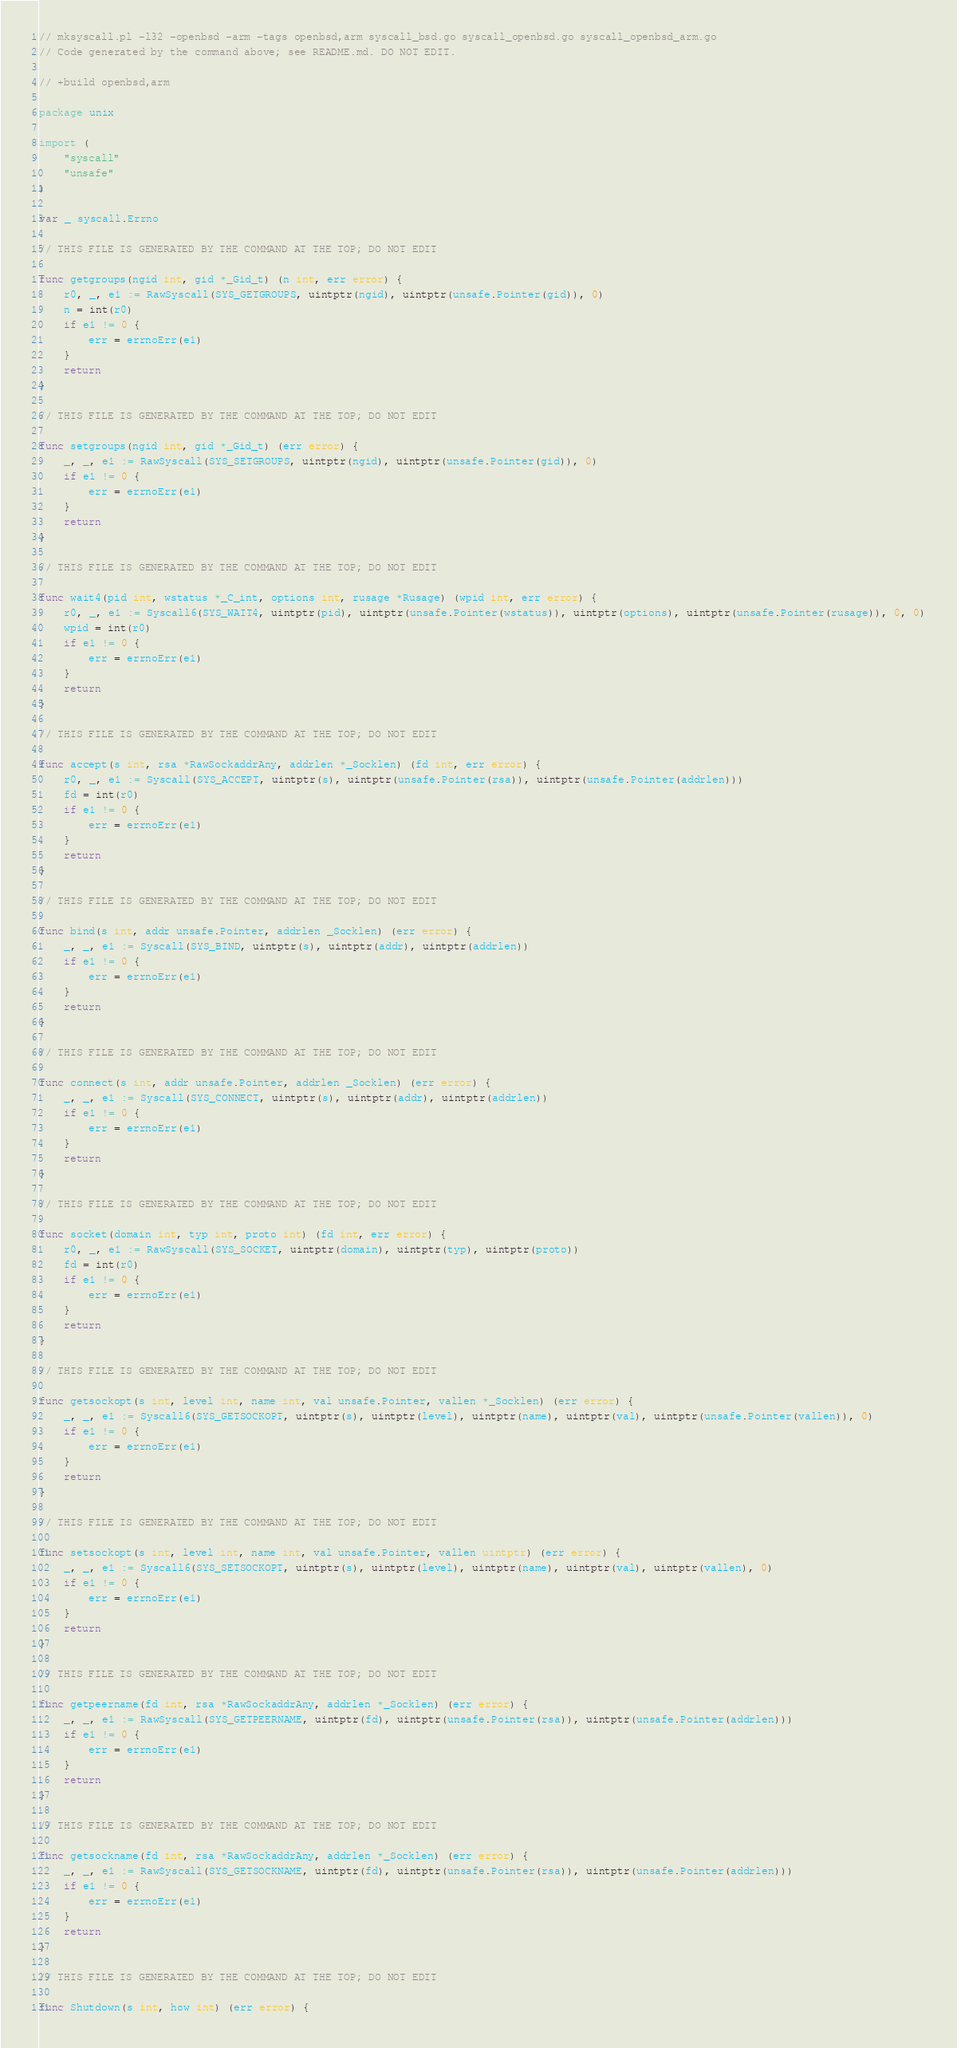Convert code to text. <code><loc_0><loc_0><loc_500><loc_500><_Go_>// mksyscall.pl -l32 -openbsd -arm -tags openbsd,arm syscall_bsd.go syscall_openbsd.go syscall_openbsd_arm.go
// Code generated by the command above; see README.md. DO NOT EDIT.

// +build openbsd,arm

package unix

import (
	"syscall"
	"unsafe"
)

var _ syscall.Errno

// THIS FILE IS GENERATED BY THE COMMAND AT THE TOP; DO NOT EDIT

func getgroups(ngid int, gid *_Gid_t) (n int, err error) {
	r0, _, e1 := RawSyscall(SYS_GETGROUPS, uintptr(ngid), uintptr(unsafe.Pointer(gid)), 0)
	n = int(r0)
	if e1 != 0 {
		err = errnoErr(e1)
	}
	return
}

// THIS FILE IS GENERATED BY THE COMMAND AT THE TOP; DO NOT EDIT

func setgroups(ngid int, gid *_Gid_t) (err error) {
	_, _, e1 := RawSyscall(SYS_SETGROUPS, uintptr(ngid), uintptr(unsafe.Pointer(gid)), 0)
	if e1 != 0 {
		err = errnoErr(e1)
	}
	return
}

// THIS FILE IS GENERATED BY THE COMMAND AT THE TOP; DO NOT EDIT

func wait4(pid int, wstatus *_C_int, options int, rusage *Rusage) (wpid int, err error) {
	r0, _, e1 := Syscall6(SYS_WAIT4, uintptr(pid), uintptr(unsafe.Pointer(wstatus)), uintptr(options), uintptr(unsafe.Pointer(rusage)), 0, 0)
	wpid = int(r0)
	if e1 != 0 {
		err = errnoErr(e1)
	}
	return
}

// THIS FILE IS GENERATED BY THE COMMAND AT THE TOP; DO NOT EDIT

func accept(s int, rsa *RawSockaddrAny, addrlen *_Socklen) (fd int, err error) {
	r0, _, e1 := Syscall(SYS_ACCEPT, uintptr(s), uintptr(unsafe.Pointer(rsa)), uintptr(unsafe.Pointer(addrlen)))
	fd = int(r0)
	if e1 != 0 {
		err = errnoErr(e1)
	}
	return
}

// THIS FILE IS GENERATED BY THE COMMAND AT THE TOP; DO NOT EDIT

func bind(s int, addr unsafe.Pointer, addrlen _Socklen) (err error) {
	_, _, e1 := Syscall(SYS_BIND, uintptr(s), uintptr(addr), uintptr(addrlen))
	if e1 != 0 {
		err = errnoErr(e1)
	}
	return
}

// THIS FILE IS GENERATED BY THE COMMAND AT THE TOP; DO NOT EDIT

func connect(s int, addr unsafe.Pointer, addrlen _Socklen) (err error) {
	_, _, e1 := Syscall(SYS_CONNECT, uintptr(s), uintptr(addr), uintptr(addrlen))
	if e1 != 0 {
		err = errnoErr(e1)
	}
	return
}

// THIS FILE IS GENERATED BY THE COMMAND AT THE TOP; DO NOT EDIT

func socket(domain int, typ int, proto int) (fd int, err error) {
	r0, _, e1 := RawSyscall(SYS_SOCKET, uintptr(domain), uintptr(typ), uintptr(proto))
	fd = int(r0)
	if e1 != 0 {
		err = errnoErr(e1)
	}
	return
}

// THIS FILE IS GENERATED BY THE COMMAND AT THE TOP; DO NOT EDIT

func getsockopt(s int, level int, name int, val unsafe.Pointer, vallen *_Socklen) (err error) {
	_, _, e1 := Syscall6(SYS_GETSOCKOPT, uintptr(s), uintptr(level), uintptr(name), uintptr(val), uintptr(unsafe.Pointer(vallen)), 0)
	if e1 != 0 {
		err = errnoErr(e1)
	}
	return
}

// THIS FILE IS GENERATED BY THE COMMAND AT THE TOP; DO NOT EDIT

func setsockopt(s int, level int, name int, val unsafe.Pointer, vallen uintptr) (err error) {
	_, _, e1 := Syscall6(SYS_SETSOCKOPT, uintptr(s), uintptr(level), uintptr(name), uintptr(val), uintptr(vallen), 0)
	if e1 != 0 {
		err = errnoErr(e1)
	}
	return
}

// THIS FILE IS GENERATED BY THE COMMAND AT THE TOP; DO NOT EDIT

func getpeername(fd int, rsa *RawSockaddrAny, addrlen *_Socklen) (err error) {
	_, _, e1 := RawSyscall(SYS_GETPEERNAME, uintptr(fd), uintptr(unsafe.Pointer(rsa)), uintptr(unsafe.Pointer(addrlen)))
	if e1 != 0 {
		err = errnoErr(e1)
	}
	return
}

// THIS FILE IS GENERATED BY THE COMMAND AT THE TOP; DO NOT EDIT

func getsockname(fd int, rsa *RawSockaddrAny, addrlen *_Socklen) (err error) {
	_, _, e1 := RawSyscall(SYS_GETSOCKNAME, uintptr(fd), uintptr(unsafe.Pointer(rsa)), uintptr(unsafe.Pointer(addrlen)))
	if e1 != 0 {
		err = errnoErr(e1)
	}
	return
}

// THIS FILE IS GENERATED BY THE COMMAND AT THE TOP; DO NOT EDIT

func Shutdown(s int, how int) (err error) {</code> 